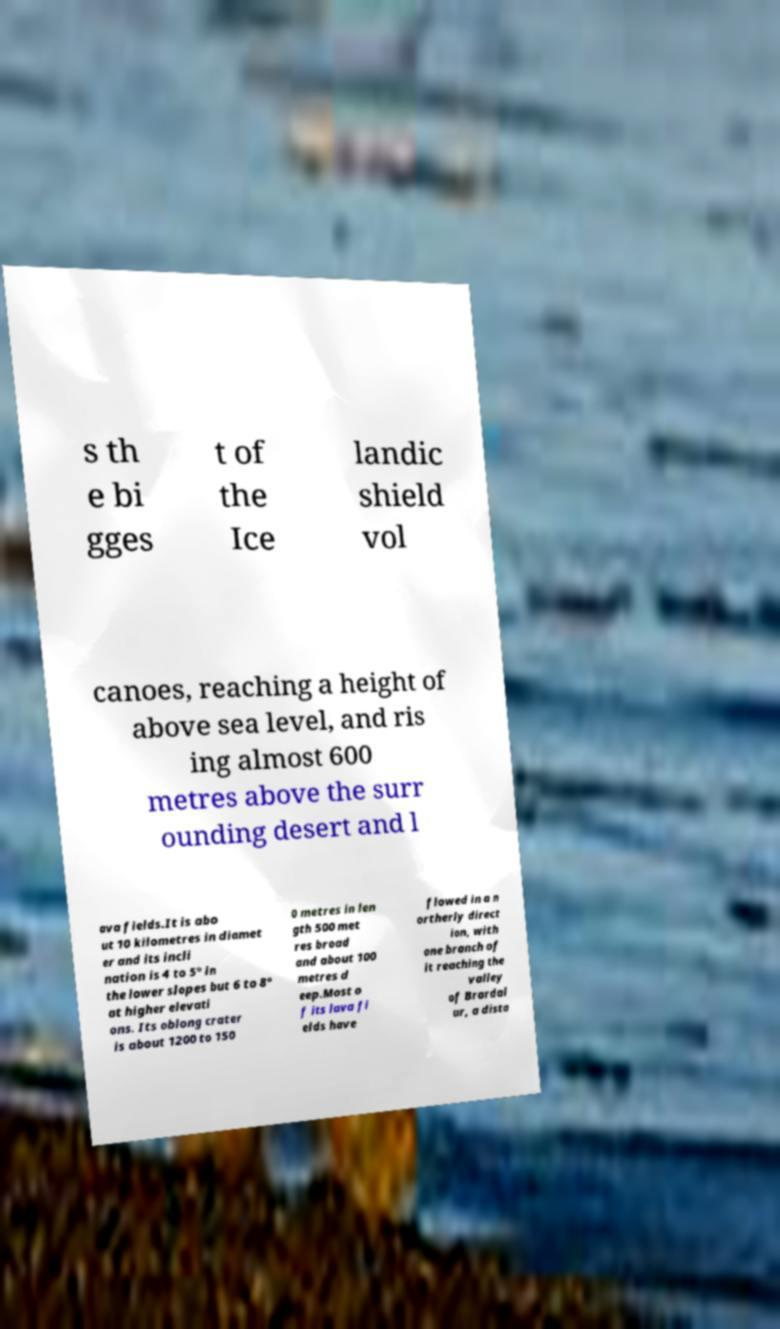For documentation purposes, I need the text within this image transcribed. Could you provide that? s th e bi gges t of the Ice landic shield vol canoes, reaching a height of above sea level, and ris ing almost 600 metres above the surr ounding desert and l ava fields.It is abo ut 10 kilometres in diamet er and its incli nation is 4 to 5° in the lower slopes but 6 to 8° at higher elevati ons. Its oblong crater is about 1200 to 150 0 metres in len gth 500 met res broad and about 100 metres d eep.Most o f its lava fi elds have flowed in a n ortherly direct ion, with one branch of it reaching the valley of Brardal ur, a dista 